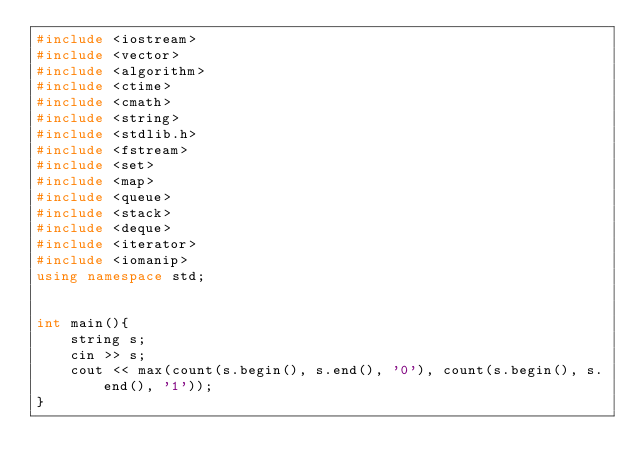Convert code to text. <code><loc_0><loc_0><loc_500><loc_500><_C++_>#include <iostream>
#include <vector>
#include <algorithm>
#include <ctime>
#include <cmath>
#include <string>
#include <stdlib.h>
#include <fstream>
#include <set>
#include <map>
#include <queue>
#include <stack>
#include <deque>
#include <iterator>
#include <iomanip>
using namespace std;


int main(){
    string s;
    cin >> s;
    cout << max(count(s.begin(), s.end(), '0'), count(s.begin(), s.end(), '1'));
}</code> 